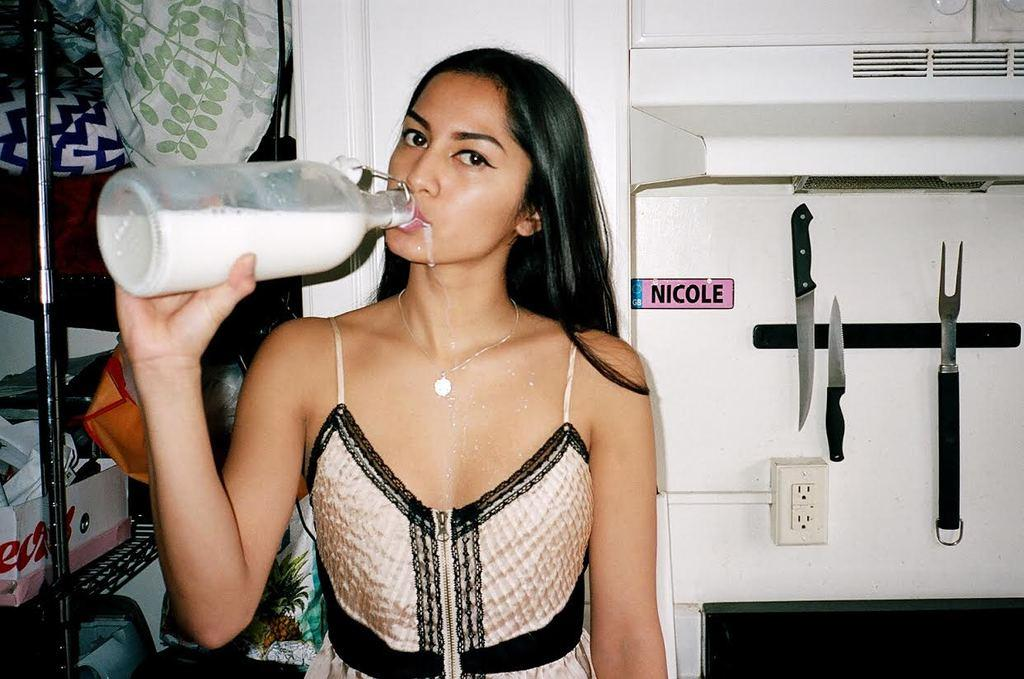Who is the main subject in the image? There is a woman in the picture. What is the woman doing in the image? The woman is drinking milk from a bottle. What utensils can be seen in the background of the image? There is a knife and a fork in the background of the image. What type of record is the woman listening to in the image? There is no record present in the image; the woman is drinking milk from a bottle. How does the woman move around in the image? The woman is not moving around in the image; she is stationary while drinking milk from a bottle. 